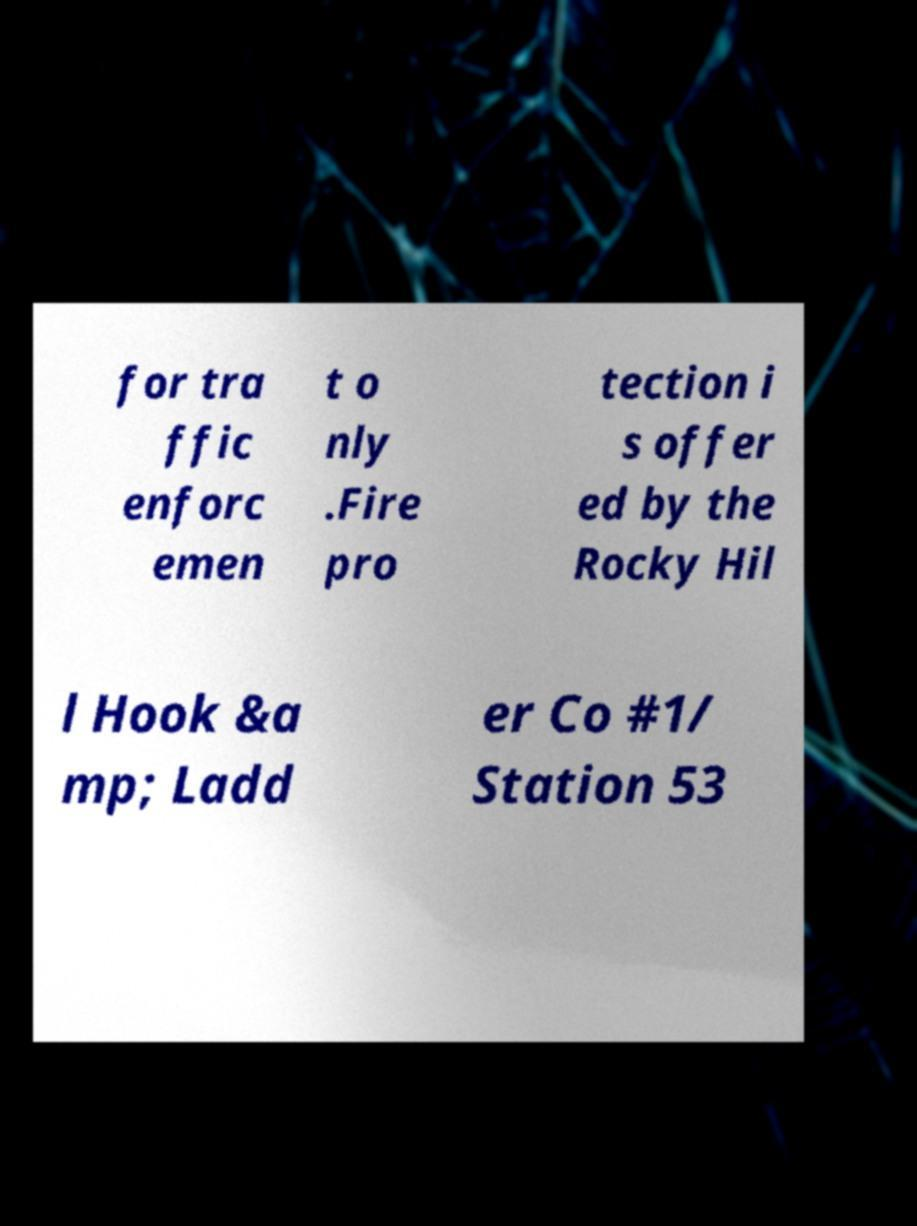Please identify and transcribe the text found in this image. for tra ffic enforc emen t o nly .Fire pro tection i s offer ed by the Rocky Hil l Hook &a mp; Ladd er Co #1/ Station 53 